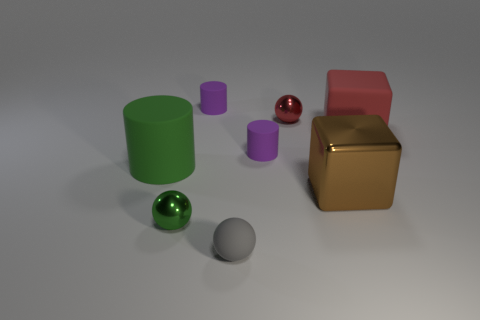How many other things are the same shape as the brown shiny object? 1 